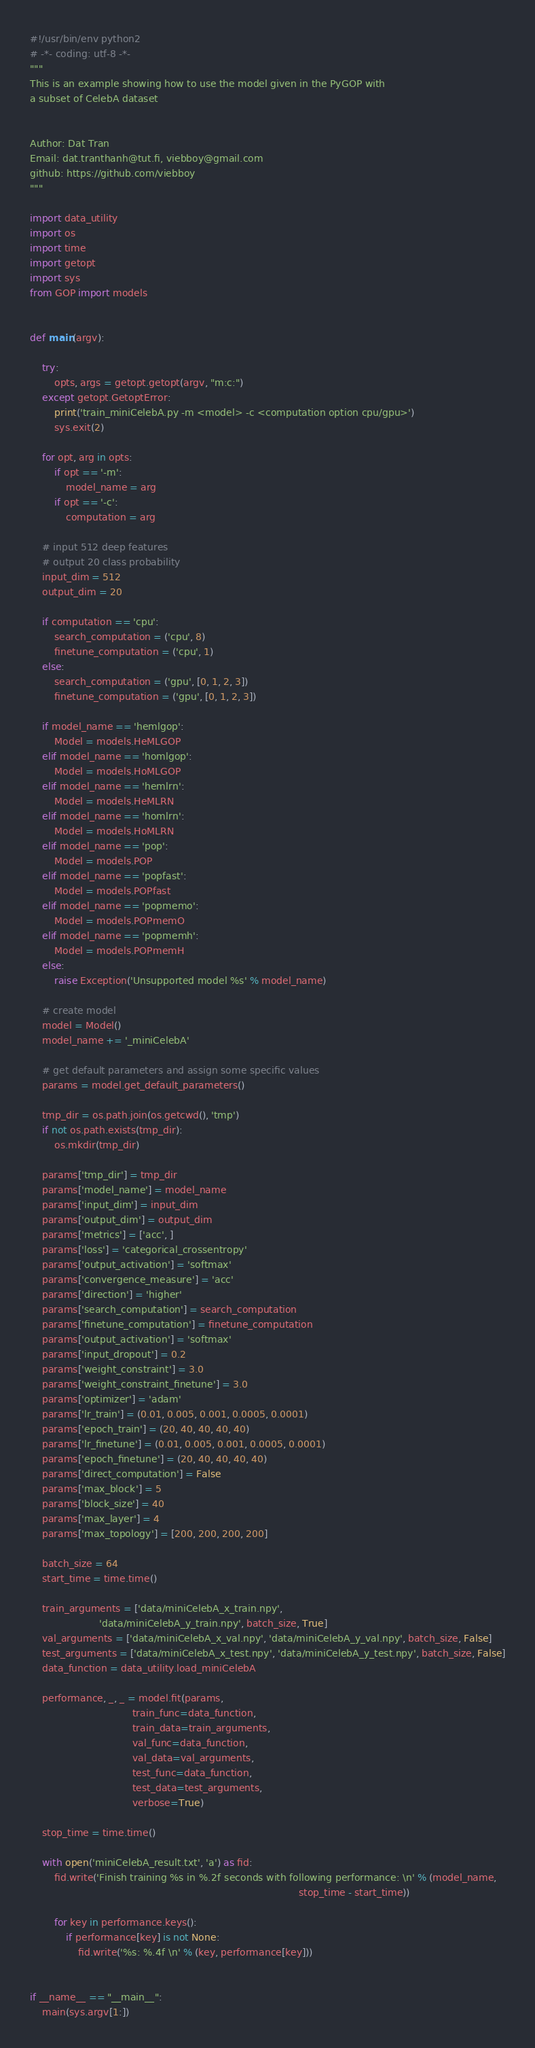<code> <loc_0><loc_0><loc_500><loc_500><_Python_>#!/usr/bin/env python2
# -*- coding: utf-8 -*-
"""
This is an example showing how to use the model given in the PyGOP with
a subset of CelebA dataset


Author: Dat Tran
Email: dat.tranthanh@tut.fi, viebboy@gmail.com
github: https://github.com/viebboy
"""

import data_utility
import os
import time
import getopt
import sys
from GOP import models


def main(argv):

    try:
        opts, args = getopt.getopt(argv, "m:c:")
    except getopt.GetoptError:
        print('train_miniCelebA.py -m <model> -c <computation option cpu/gpu>')
        sys.exit(2)

    for opt, arg in opts:
        if opt == '-m':
            model_name = arg
        if opt == '-c':
            computation = arg

    # input 512 deep features
    # output 20 class probability
    input_dim = 512
    output_dim = 20

    if computation == 'cpu':
        search_computation = ('cpu', 8)
        finetune_computation = ('cpu', 1)
    else:
        search_computation = ('gpu', [0, 1, 2, 3])
        finetune_computation = ('gpu', [0, 1, 2, 3])

    if model_name == 'hemlgop':
        Model = models.HeMLGOP
    elif model_name == 'homlgop':
        Model = models.HoMLGOP
    elif model_name == 'hemlrn':
        Model = models.HeMLRN
    elif model_name == 'homlrn':
        Model = models.HoMLRN
    elif model_name == 'pop':
        Model = models.POP
    elif model_name == 'popfast':
        Model = models.POPfast
    elif model_name == 'popmemo':
        Model = models.POPmemO
    elif model_name == 'popmemh':
        Model = models.POPmemH
    else:
        raise Exception('Unsupported model %s' % model_name)

    # create model
    model = Model()
    model_name += '_miniCelebA'

    # get default parameters and assign some specific values
    params = model.get_default_parameters()

    tmp_dir = os.path.join(os.getcwd(), 'tmp')
    if not os.path.exists(tmp_dir):
        os.mkdir(tmp_dir)

    params['tmp_dir'] = tmp_dir
    params['model_name'] = model_name
    params['input_dim'] = input_dim
    params['output_dim'] = output_dim
    params['metrics'] = ['acc', ]
    params['loss'] = 'categorical_crossentropy'
    params['output_activation'] = 'softmax'
    params['convergence_measure'] = 'acc'
    params['direction'] = 'higher'
    params['search_computation'] = search_computation
    params['finetune_computation'] = finetune_computation
    params['output_activation'] = 'softmax'
    params['input_dropout'] = 0.2
    params['weight_constraint'] = 3.0
    params['weight_constraint_finetune'] = 3.0
    params['optimizer'] = 'adam'
    params['lr_train'] = (0.01, 0.005, 0.001, 0.0005, 0.0001)
    params['epoch_train'] = (20, 40, 40, 40, 40)
    params['lr_finetune'] = (0.01, 0.005, 0.001, 0.0005, 0.0001)
    params['epoch_finetune'] = (20, 40, 40, 40, 40)
    params['direct_computation'] = False
    params['max_block'] = 5
    params['block_size'] = 40
    params['max_layer'] = 4
    params['max_topology'] = [200, 200, 200, 200]

    batch_size = 64
    start_time = time.time()

    train_arguments = ['data/miniCelebA_x_train.npy',
                       'data/miniCelebA_y_train.npy', batch_size, True]
    val_arguments = ['data/miniCelebA_x_val.npy', 'data/miniCelebA_y_val.npy', batch_size, False]
    test_arguments = ['data/miniCelebA_x_test.npy', 'data/miniCelebA_y_test.npy', batch_size, False]
    data_function = data_utility.load_miniCelebA

    performance, _, _ = model.fit(params,
                                  train_func=data_function,
                                  train_data=train_arguments,
                                  val_func=data_function,
                                  val_data=val_arguments,
                                  test_func=data_function,
                                  test_data=test_arguments,
                                  verbose=True)

    stop_time = time.time()

    with open('miniCelebA_result.txt', 'a') as fid:
        fid.write('Finish training %s in %.2f seconds with following performance: \n' % (model_name,
                                                                                         stop_time - start_time))

        for key in performance.keys():
            if performance[key] is not None:
                fid.write('%s: %.4f \n' % (key, performance[key]))


if __name__ == "__main__":
    main(sys.argv[1:])
</code> 